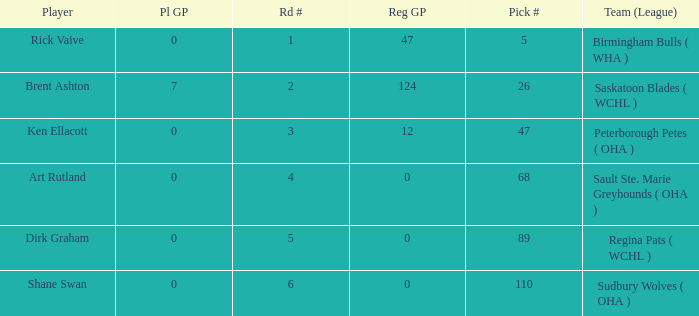How many reg GP for rick vaive in round 1? None. 